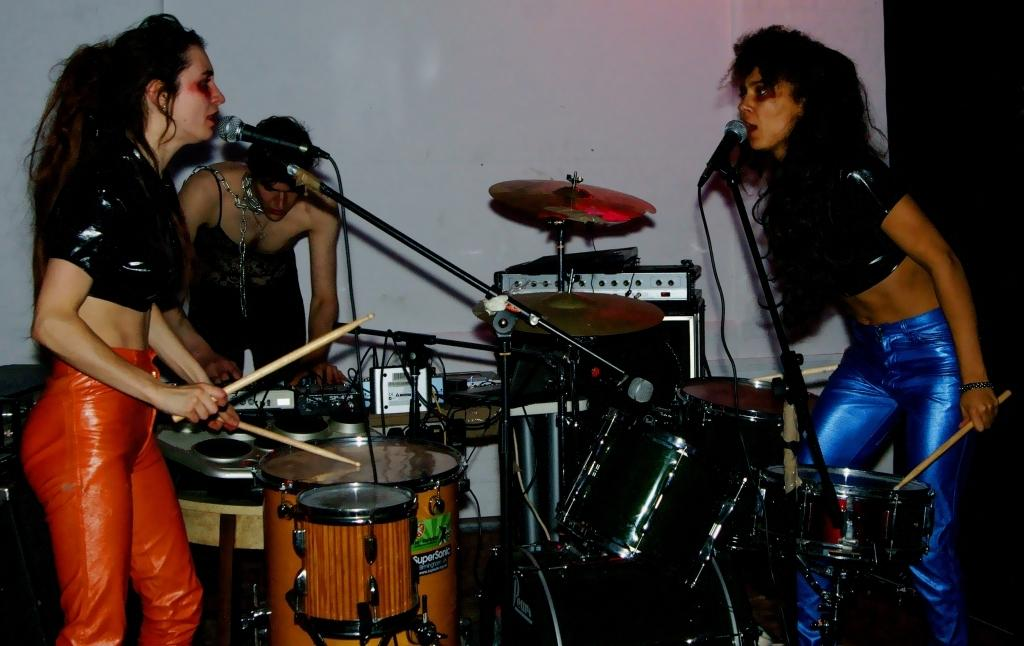How many musicians are in the image? There are three musicians in the image. What is the gender of the musicians? The musicians are women. What are the women doing in the image? Each woman is playing an instrument. Can you describe the setup in front of the musicians? There are two microphones with mic holders in front of two of the women. What is the woman holding a stick doing? It is not clear from the image what the woman holding a stick is doing with it. What type of punishment is being discussed in the image? There is no text or discussion of punishment in the image; it features three women musicians playing instruments. 